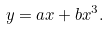<formula> <loc_0><loc_0><loc_500><loc_500>y = a x + b x ^ { 3 } .</formula> 